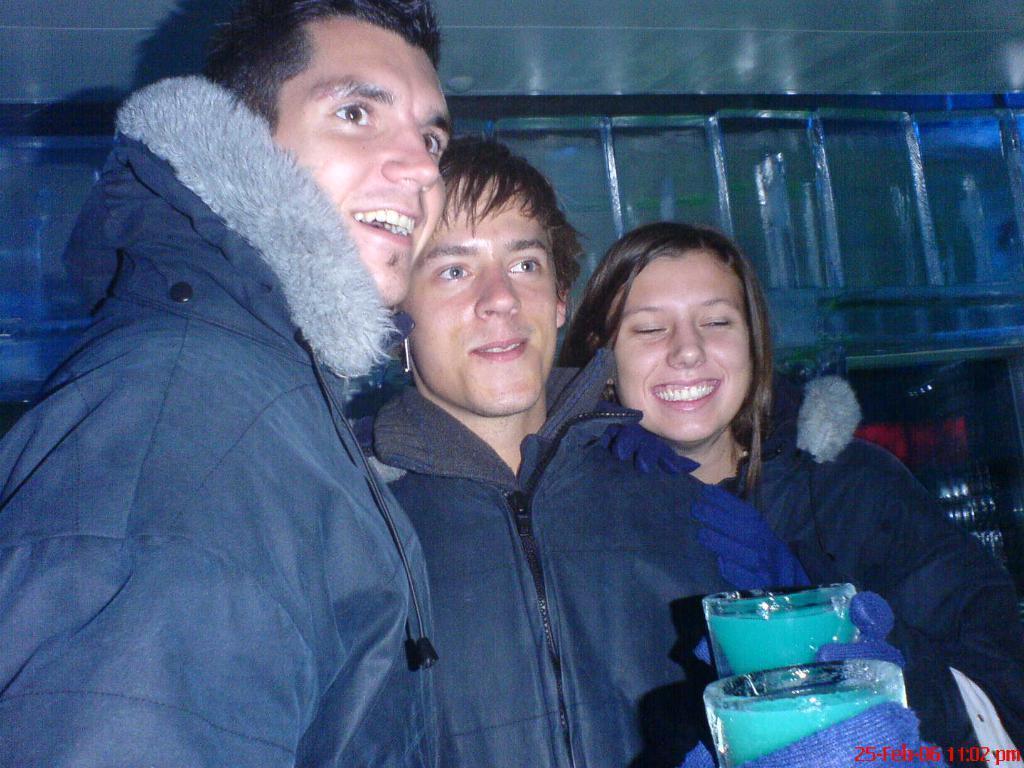Can you describe this image briefly? In this image we can see three persons standing and two persons are holding objects looks like glass and an iron railing in the background. 